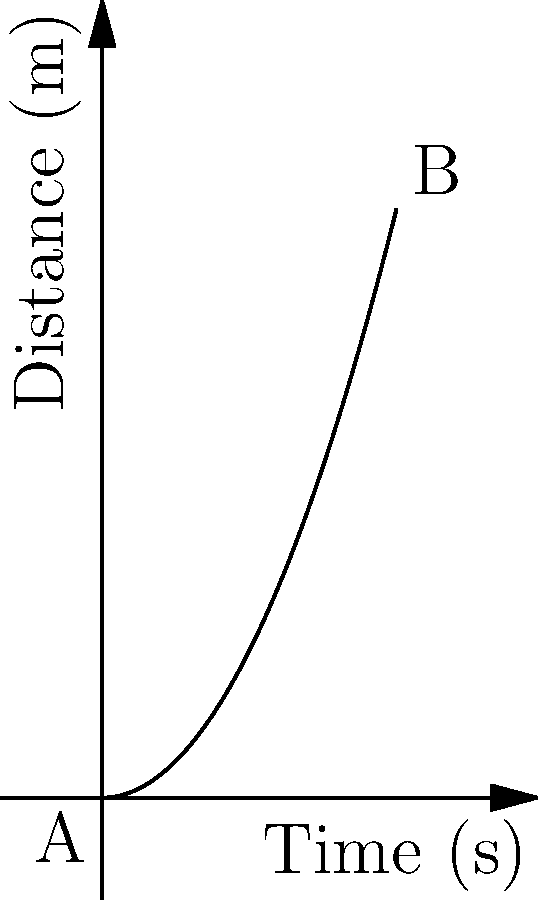During a pursuit, a K9 unit's movement is represented by the distance-time graph above. The chase lasts for 10 seconds, covering a total distance of 20 meters. Calculate:

a) The average speed of the K9 unit during the entire pursuit.
b) The instantaneous speed of the K9 unit at t = 5 seconds.
c) The average acceleration of the K9 unit over the 10-second interval. Let's solve this step-by-step:

a) Average speed:
   The average speed is given by the total distance traveled divided by the total time taken.
   $$v_{avg} = \frac{\Delta d}{\Delta t} = \frac{20 \text{ m}}{10 \text{ s}} = 2 \text{ m/s}$$

b) Instantaneous speed at t = 5 s:
   The distance-time graph is a parabola, representing the equation $d = 0.2t^2$.
   To find the instantaneous speed, we need to calculate the derivative of this equation:
   $$v(t) = \frac{d}{dt}(0.2t^2) = 0.4t$$
   At t = 5 s:
   $$v(5) = 0.4 \cdot 5 = 2 \text{ m/s}$$

c) Average acceleration:
   The average acceleration is the change in velocity over time.
   Initial velocity (at t = 0): $v_i = 0.4 \cdot 0 = 0 \text{ m/s}$
   Final velocity (at t = 10): $v_f = 0.4 \cdot 10 = 4 \text{ m/s}$
   $$a_{avg} = \frac{\Delta v}{\Delta t} = \frac{v_f - v_i}{\Delta t} = \frac{4 \text{ m/s} - 0 \text{ m/s}}{10 \text{ s}} = 0.4 \text{ m/s}^2$$
Answer: a) 2 m/s
b) 2 m/s
c) 0.4 m/s² 